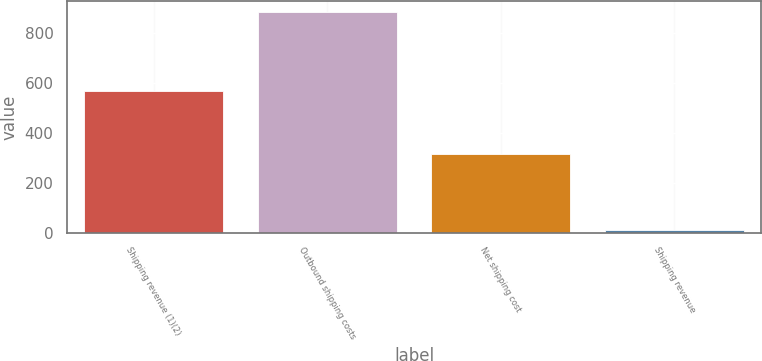Convert chart to OTSL. <chart><loc_0><loc_0><loc_500><loc_500><bar_chart><fcel>Shipping revenue (1)(2)<fcel>Outbound shipping costs<fcel>Net shipping cost<fcel>Shipping revenue<nl><fcel>567<fcel>884<fcel>317<fcel>11<nl></chart> 